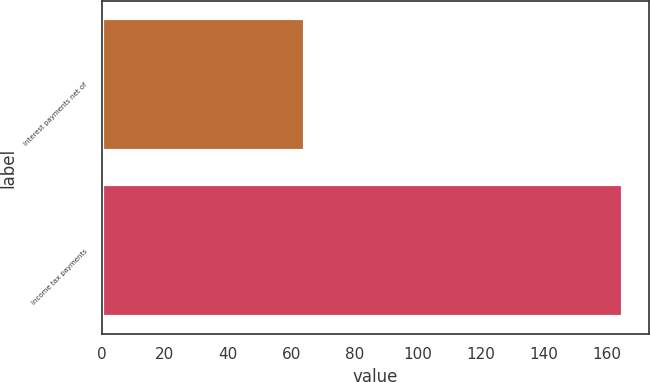Convert chart to OTSL. <chart><loc_0><loc_0><loc_500><loc_500><bar_chart><fcel>Interest payments net of<fcel>Income tax payments<nl><fcel>64.5<fcel>165.1<nl></chart> 